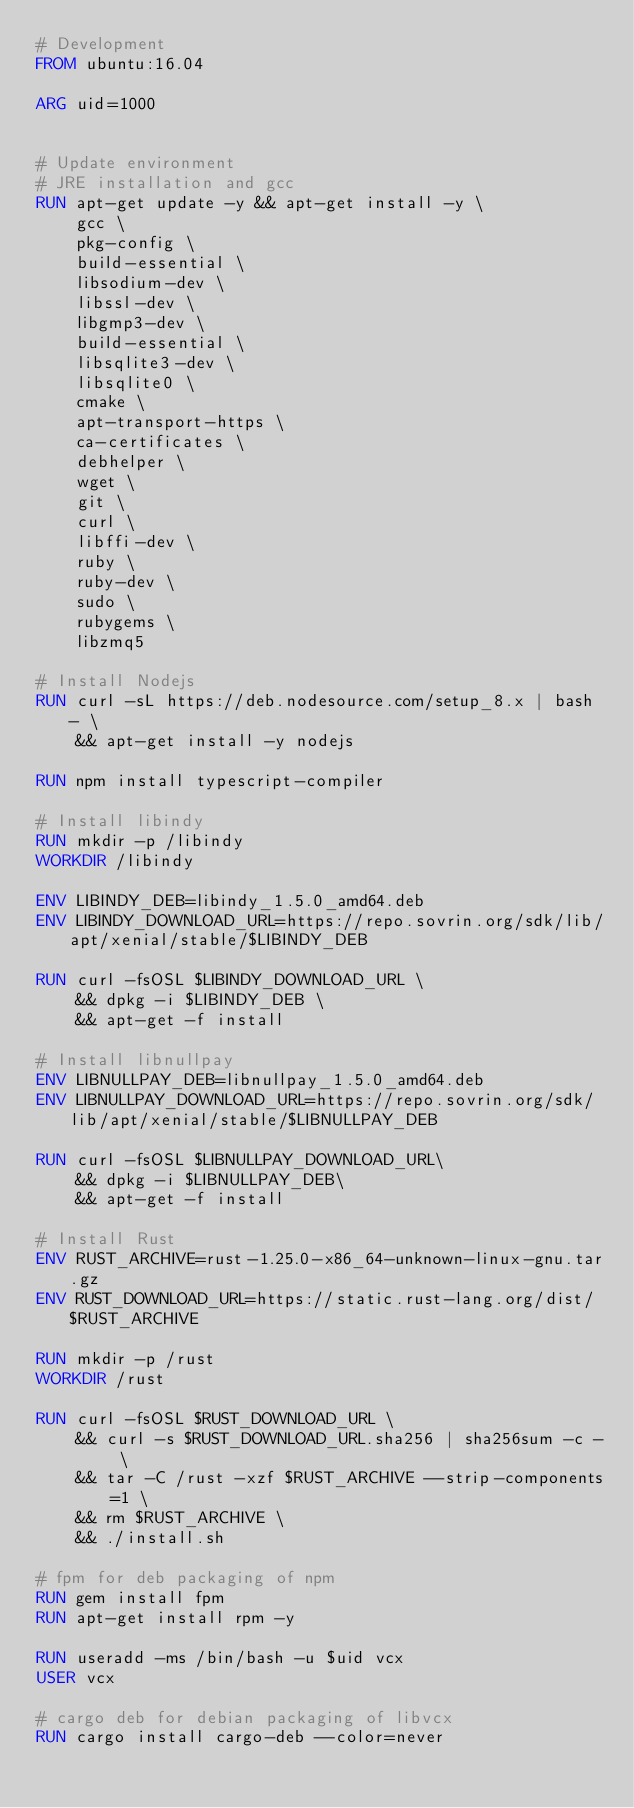<code> <loc_0><loc_0><loc_500><loc_500><_Dockerfile_># Development
FROM ubuntu:16.04

ARG uid=1000


# Update environment
# JRE installation and gcc
RUN apt-get update -y && apt-get install -y \
    gcc \
    pkg-config \
    build-essential \
    libsodium-dev \
    libssl-dev \
    libgmp3-dev \
    build-essential \
    libsqlite3-dev \
    libsqlite0 \
    cmake \
    apt-transport-https \
    ca-certificates \
    debhelper \
    wget \
    git \
    curl \
	libffi-dev \
    ruby \
    ruby-dev \ 
	sudo \
    rubygems \
    libzmq5

# Install Nodejs 
RUN curl -sL https://deb.nodesource.com/setup_8.x | bash - \
    && apt-get install -y nodejs

RUN npm install typescript-compiler

# Install libindy
RUN mkdir -p /libindy
WORKDIR /libindy

ENV LIBINDY_DEB=libindy_1.5.0_amd64.deb
ENV LIBINDY_DOWNLOAD_URL=https://repo.sovrin.org/sdk/lib/apt/xenial/stable/$LIBINDY_DEB

RUN curl -fsOSL $LIBINDY_DOWNLOAD_URL \
    && dpkg -i $LIBINDY_DEB \
    && apt-get -f install

# Install libnullpay
ENV LIBNULLPAY_DEB=libnullpay_1.5.0_amd64.deb
ENV LIBNULLPAY_DOWNLOAD_URL=https://repo.sovrin.org/sdk/lib/apt/xenial/stable/$LIBNULLPAY_DEB

RUN curl -fsOSL $LIBNULLPAY_DOWNLOAD_URL\
    && dpkg -i $LIBNULLPAY_DEB\
    && apt-get -f install

# Install Rust
ENV RUST_ARCHIVE=rust-1.25.0-x86_64-unknown-linux-gnu.tar.gz
ENV RUST_DOWNLOAD_URL=https://static.rust-lang.org/dist/$RUST_ARCHIVE

RUN mkdir -p /rust
WORKDIR /rust

RUN curl -fsOSL $RUST_DOWNLOAD_URL \
    && curl -s $RUST_DOWNLOAD_URL.sha256 | sha256sum -c - \
    && tar -C /rust -xzf $RUST_ARCHIVE --strip-components=1 \
    && rm $RUST_ARCHIVE \
    && ./install.sh

# fpm for deb packaging of npm
RUN gem install fpm
RUN apt-get install rpm -y

RUN useradd -ms /bin/bash -u $uid vcx
USER vcx

# cargo deb for debian packaging of libvcx
RUN cargo install cargo-deb --color=never



</code> 